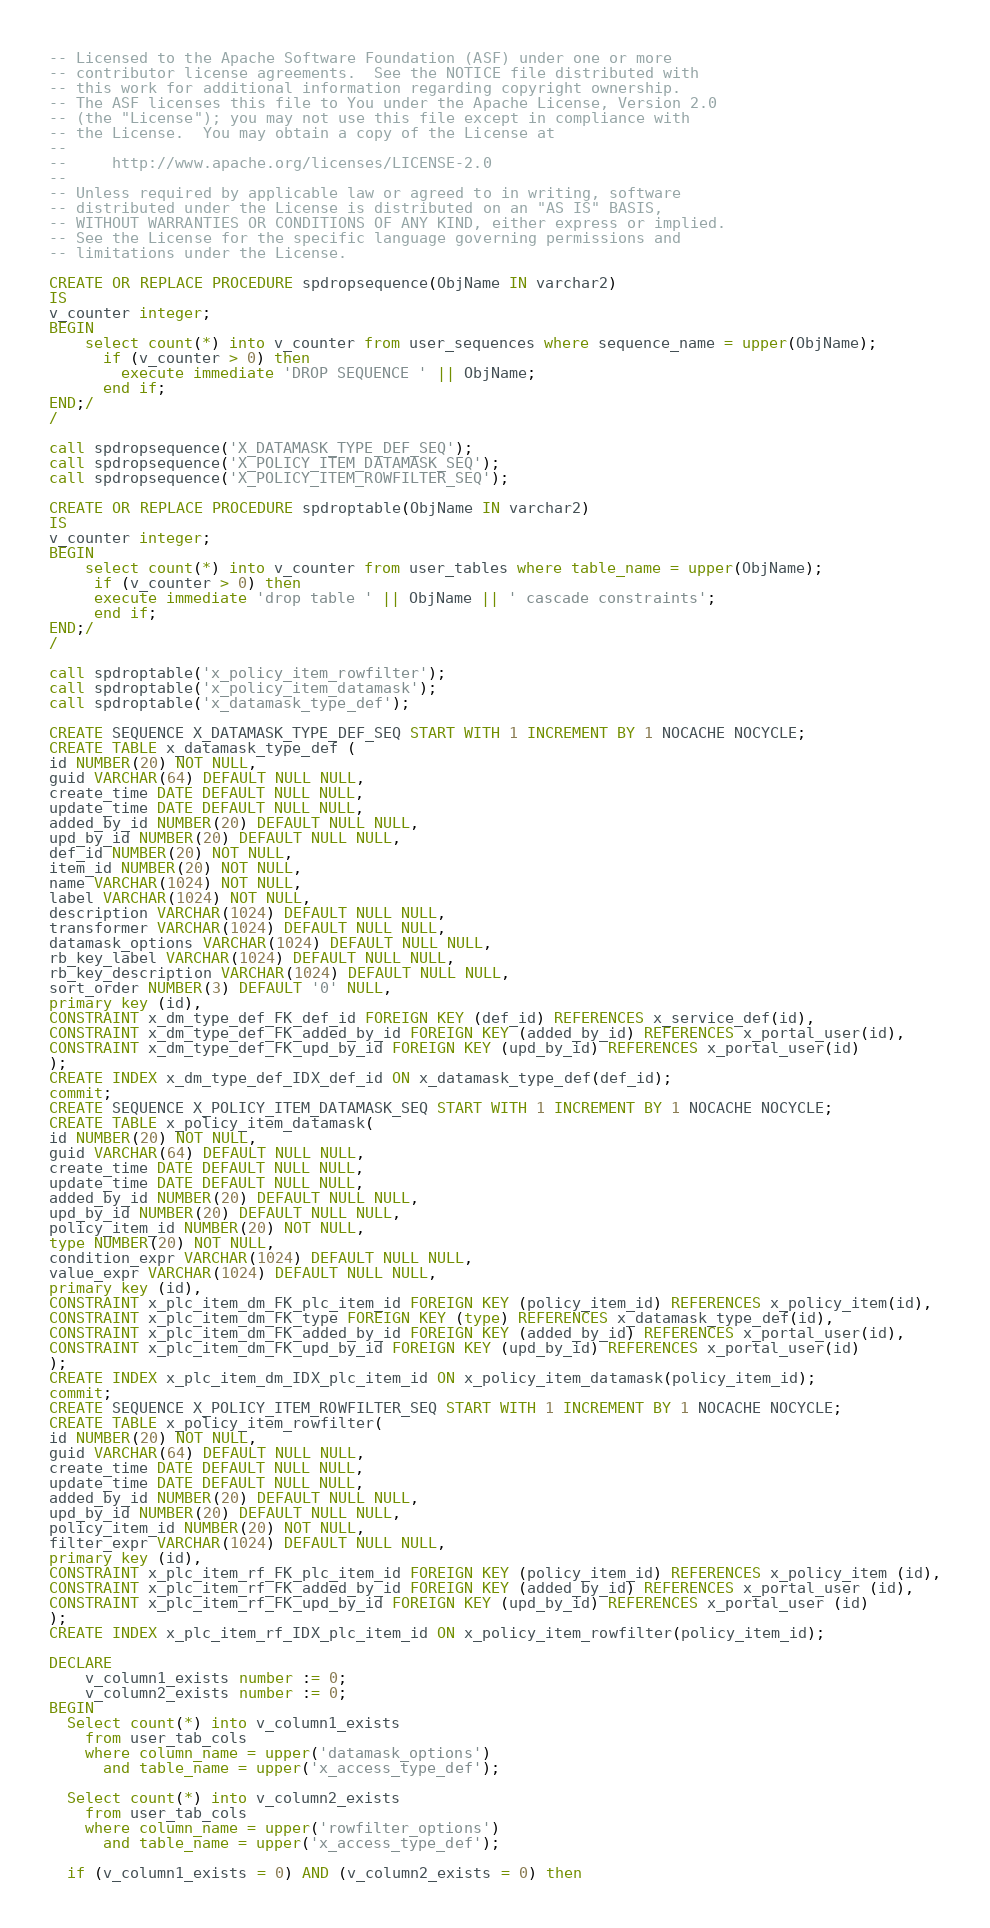<code> <loc_0><loc_0><loc_500><loc_500><_SQL_>-- Licensed to the Apache Software Foundation (ASF) under one or more
-- contributor license agreements.  See the NOTICE file distributed with
-- this work for additional information regarding copyright ownership.
-- The ASF licenses this file to You under the Apache License, Version 2.0
-- (the "License"); you may not use this file except in compliance with
-- the License.  You may obtain a copy of the License at
--
--     http://www.apache.org/licenses/LICENSE-2.0
--
-- Unless required by applicable law or agreed to in writing, software
-- distributed under the License is distributed on an "AS IS" BASIS,
-- WITHOUT WARRANTIES OR CONDITIONS OF ANY KIND, either express or implied.
-- See the License for the specific language governing permissions and
-- limitations under the License.

CREATE OR REPLACE PROCEDURE spdropsequence(ObjName IN varchar2)
IS
v_counter integer;
BEGIN
    select count(*) into v_counter from user_sequences where sequence_name = upper(ObjName);
      if (v_counter > 0) then
        execute immediate 'DROP SEQUENCE ' || ObjName;
      end if;
END;/
/

call spdropsequence('X_DATAMASK_TYPE_DEF_SEQ');
call spdropsequence('X_POLICY_ITEM_DATAMASK_SEQ');
call spdropsequence('X_POLICY_ITEM_ROWFILTER_SEQ');

CREATE OR REPLACE PROCEDURE spdroptable(ObjName IN varchar2)
IS
v_counter integer;
BEGIN
    select count(*) into v_counter from user_tables where table_name = upper(ObjName);
     if (v_counter > 0) then
     execute immediate 'drop table ' || ObjName || ' cascade constraints';
     end if;
END;/
/

call spdroptable('x_policy_item_rowfilter');
call spdroptable('x_policy_item_datamask');
call spdroptable('x_datamask_type_def');

CREATE SEQUENCE X_DATAMASK_TYPE_DEF_SEQ START WITH 1 INCREMENT BY 1 NOCACHE NOCYCLE;
CREATE TABLE x_datamask_type_def (
id NUMBER(20) NOT NULL,
guid VARCHAR(64) DEFAULT NULL NULL,
create_time DATE DEFAULT NULL NULL,
update_time DATE DEFAULT NULL NULL,
added_by_id NUMBER(20) DEFAULT NULL NULL,
upd_by_id NUMBER(20) DEFAULT NULL NULL,
def_id NUMBER(20) NOT NULL,
item_id NUMBER(20) NOT NULL,
name VARCHAR(1024) NOT NULL,
label VARCHAR(1024) NOT NULL,
description VARCHAR(1024) DEFAULT NULL NULL,
transformer VARCHAR(1024) DEFAULT NULL NULL,
datamask_options VARCHAR(1024) DEFAULT NULL NULL,
rb_key_label VARCHAR(1024) DEFAULT NULL NULL,
rb_key_description VARCHAR(1024) DEFAULT NULL NULL,
sort_order NUMBER(3) DEFAULT '0' NULL,
primary key (id),
CONSTRAINT x_dm_type_def_FK_def_id FOREIGN KEY (def_id) REFERENCES x_service_def(id),
CONSTRAINT x_dm_type_def_FK_added_by_id FOREIGN KEY (added_by_id) REFERENCES x_portal_user(id),
CONSTRAINT x_dm_type_def_FK_upd_by_id FOREIGN KEY (upd_by_id) REFERENCES x_portal_user(id)
);
CREATE INDEX x_dm_type_def_IDX_def_id ON x_datamask_type_def(def_id);
commit;
CREATE SEQUENCE X_POLICY_ITEM_DATAMASK_SEQ START WITH 1 INCREMENT BY 1 NOCACHE NOCYCLE;
CREATE TABLE x_policy_item_datamask(
id NUMBER(20) NOT NULL,
guid VARCHAR(64) DEFAULT NULL NULL,
create_time DATE DEFAULT NULL NULL,
update_time DATE DEFAULT NULL NULL,
added_by_id NUMBER(20) DEFAULT NULL NULL,
upd_by_id NUMBER(20) DEFAULT NULL NULL,
policy_item_id NUMBER(20) NOT NULL,
type NUMBER(20) NOT NULL,
condition_expr VARCHAR(1024) DEFAULT NULL NULL,
value_expr VARCHAR(1024) DEFAULT NULL NULL,
primary key (id),
CONSTRAINT x_plc_item_dm_FK_plc_item_id FOREIGN KEY (policy_item_id) REFERENCES x_policy_item(id),
CONSTRAINT x_plc_item_dm_FK_type FOREIGN KEY (type) REFERENCES x_datamask_type_def(id),
CONSTRAINT x_plc_item_dm_FK_added_by_id FOREIGN KEY (added_by_id) REFERENCES x_portal_user(id),
CONSTRAINT x_plc_item_dm_FK_upd_by_id FOREIGN KEY (upd_by_id) REFERENCES x_portal_user(id)
);
CREATE INDEX x_plc_item_dm_IDX_plc_item_id ON x_policy_item_datamask(policy_item_id);
commit;
CREATE SEQUENCE X_POLICY_ITEM_ROWFILTER_SEQ START WITH 1 INCREMENT BY 1 NOCACHE NOCYCLE;
CREATE TABLE x_policy_item_rowfilter(
id NUMBER(20) NOT NULL,
guid VARCHAR(64) DEFAULT NULL NULL,
create_time DATE DEFAULT NULL NULL,
update_time DATE DEFAULT NULL NULL,
added_by_id NUMBER(20) DEFAULT NULL NULL,
upd_by_id NUMBER(20) DEFAULT NULL NULL,
policy_item_id NUMBER(20) NOT NULL, 
filter_expr VARCHAR(1024) DEFAULT NULL NULL,
primary key (id),
CONSTRAINT x_plc_item_rf_FK_plc_item_id FOREIGN KEY (policy_item_id) REFERENCES x_policy_item (id),
CONSTRAINT x_plc_item_rf_FK_added_by_id FOREIGN KEY (added_by_id) REFERENCES x_portal_user (id),
CONSTRAINT x_plc_item_rf_FK_upd_by_id FOREIGN KEY (upd_by_id) REFERENCES x_portal_user (id)
);
CREATE INDEX x_plc_item_rf_IDX_plc_item_id ON x_policy_item_rowfilter(policy_item_id);

DECLARE
	v_column1_exists number := 0;
	v_column2_exists number := 0;
BEGIN
  Select count(*) into v_column1_exists
    from user_tab_cols
    where column_name = upper('datamask_options')
      and table_name = upper('x_access_type_def');

  Select count(*) into v_column2_exists
    from user_tab_cols
    where column_name = upper('rowfilter_options')
      and table_name = upper('x_access_type_def');

  if (v_column1_exists = 0) AND (v_column2_exists = 0) then</code> 